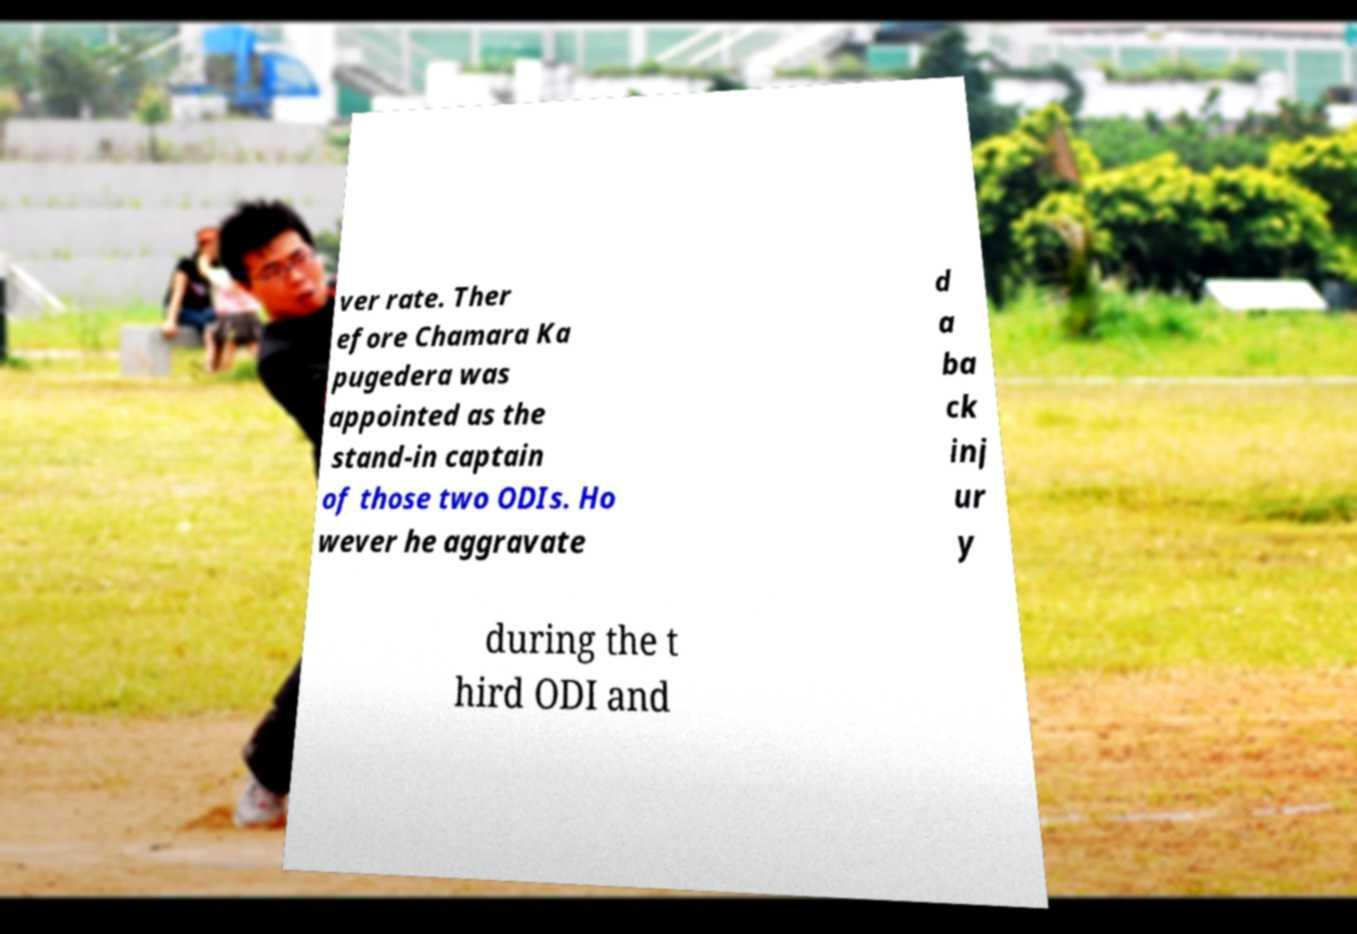There's text embedded in this image that I need extracted. Can you transcribe it verbatim? ver rate. Ther efore Chamara Ka pugedera was appointed as the stand-in captain of those two ODIs. Ho wever he aggravate d a ba ck inj ur y during the t hird ODI and 